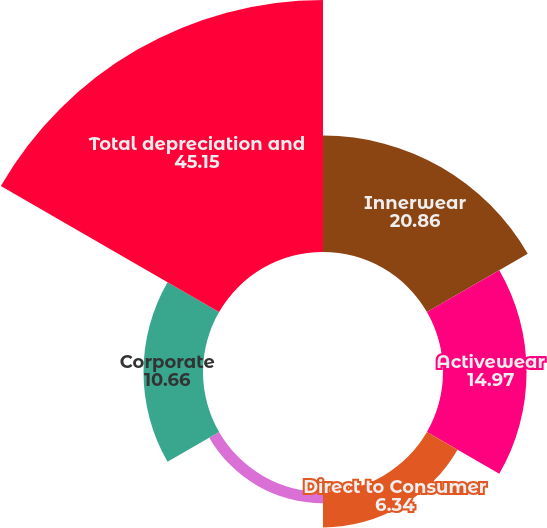<chart> <loc_0><loc_0><loc_500><loc_500><pie_chart><fcel>Innerwear<fcel>Activewear<fcel>Direct to Consumer<fcel>International<fcel>Corporate<fcel>Total depreciation and<nl><fcel>20.86%<fcel>14.97%<fcel>6.34%<fcel>2.03%<fcel>10.66%<fcel>45.15%<nl></chart> 